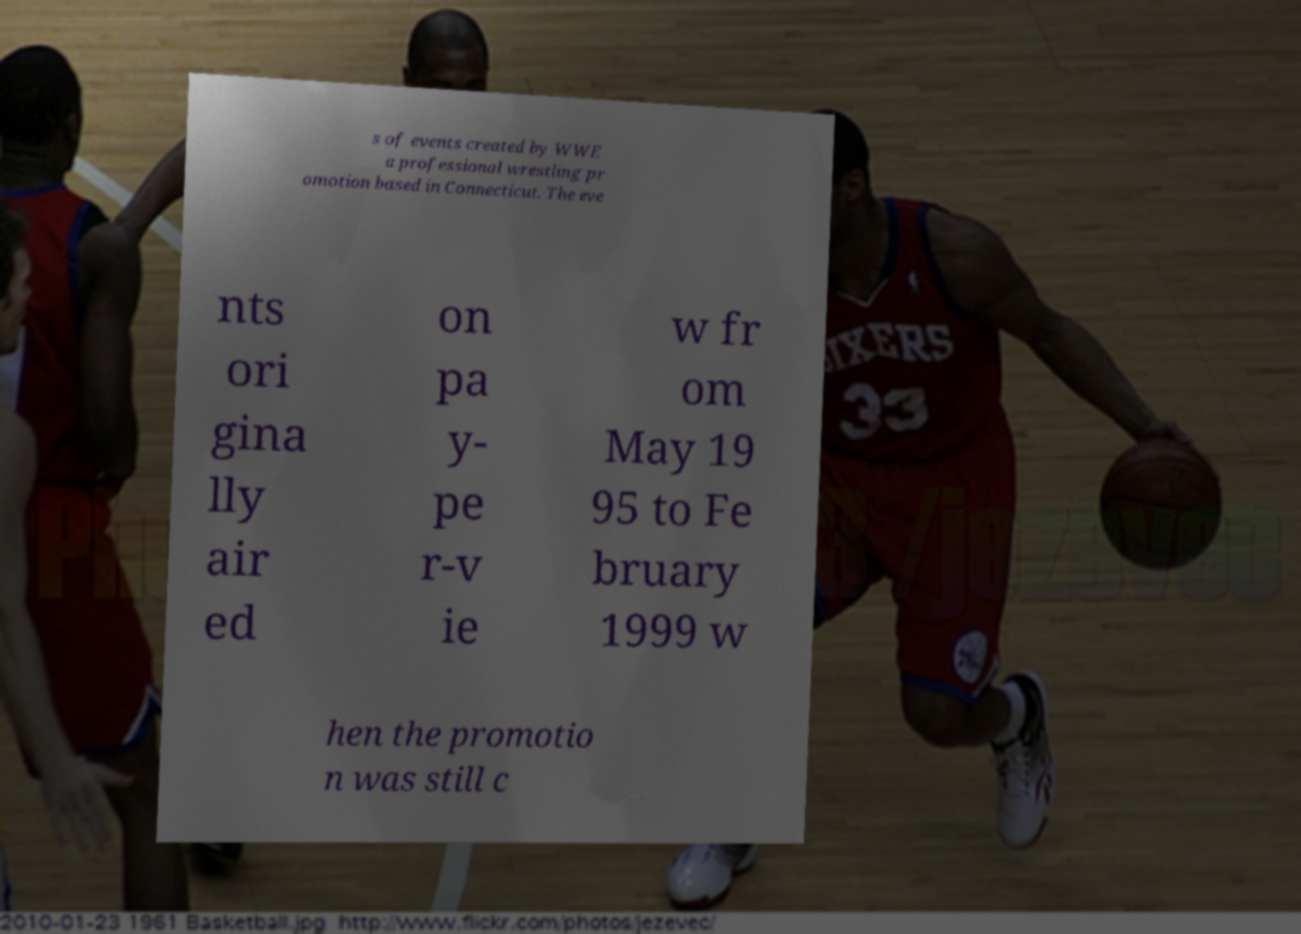I need the written content from this picture converted into text. Can you do that? s of events created by WWE a professional wrestling pr omotion based in Connecticut. The eve nts ori gina lly air ed on pa y- pe r-v ie w fr om May 19 95 to Fe bruary 1999 w hen the promotio n was still c 